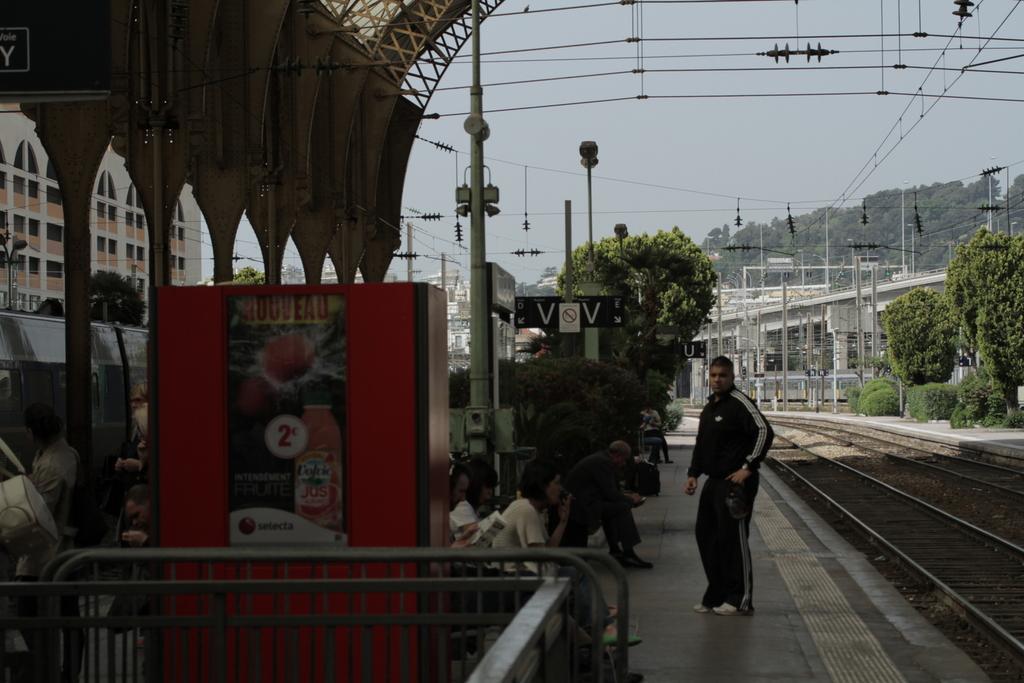Could you give a brief overview of what you see in this image? This picture is taken inside the railway station. In this image, on the right side, we can see some trees and plants, electric pole, electric wires. On the left side, we can see a metal rod and a group of people sitting on the bench, box, pillars, building, trees, electric wires, electric pole. In the middle of the image, we can see a man standing on the floor. In the background, we can see some trees, plants, electric pole, electric wires, bridge, building. At the top, we can see a sky, at the bottom, we can see some stones on the railway track. 